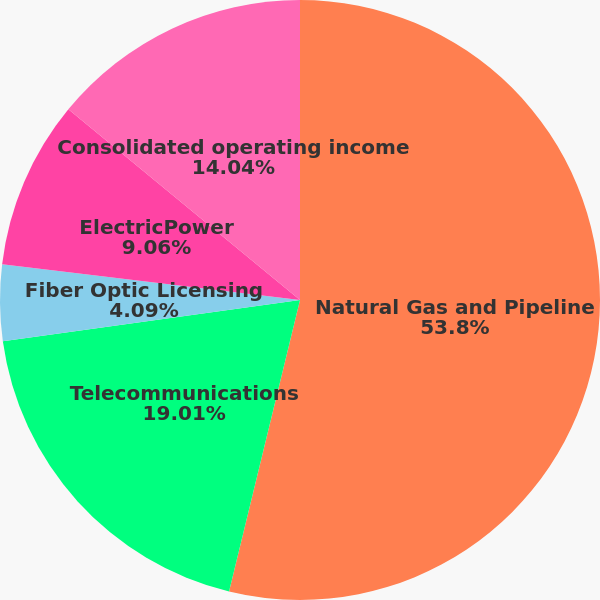<chart> <loc_0><loc_0><loc_500><loc_500><pie_chart><fcel>Natural Gas and Pipeline<fcel>Telecommunications<fcel>Fiber Optic Licensing<fcel>ElectricPower<fcel>Consolidated operating income<nl><fcel>53.8%<fcel>19.01%<fcel>4.09%<fcel>9.06%<fcel>14.04%<nl></chart> 